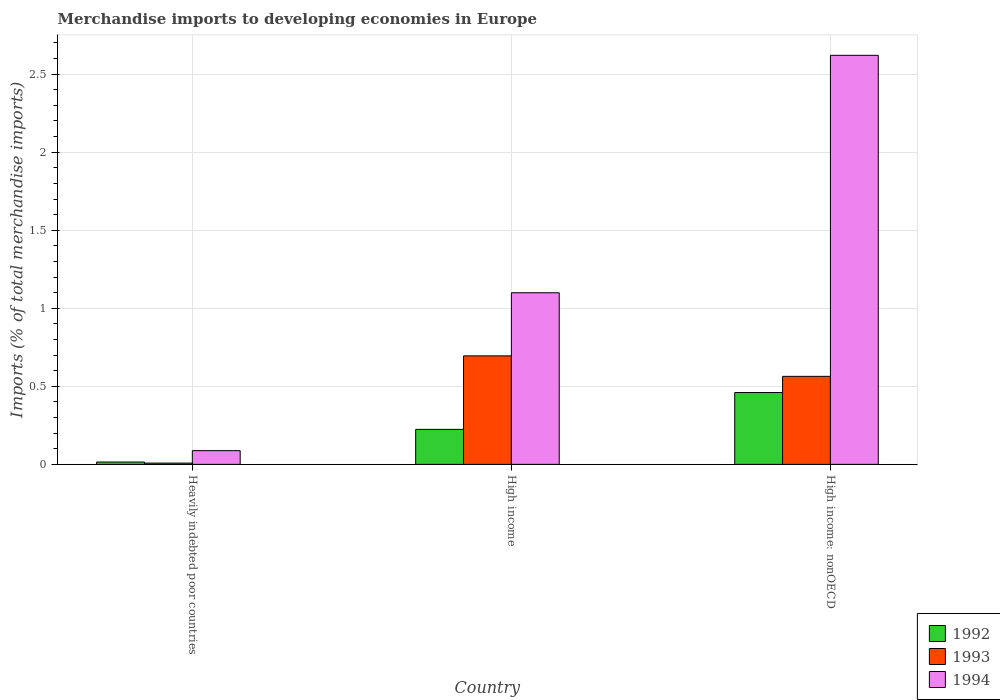Are the number of bars per tick equal to the number of legend labels?
Your response must be concise. Yes. Are the number of bars on each tick of the X-axis equal?
Ensure brevity in your answer.  Yes. How many bars are there on the 3rd tick from the right?
Give a very brief answer. 3. What is the label of the 3rd group of bars from the left?
Make the answer very short. High income: nonOECD. What is the percentage total merchandise imports in 1994 in High income?
Your answer should be very brief. 1.1. Across all countries, what is the maximum percentage total merchandise imports in 1993?
Provide a short and direct response. 0.7. Across all countries, what is the minimum percentage total merchandise imports in 1994?
Make the answer very short. 0.09. In which country was the percentage total merchandise imports in 1994 maximum?
Offer a terse response. High income: nonOECD. In which country was the percentage total merchandise imports in 1993 minimum?
Give a very brief answer. Heavily indebted poor countries. What is the total percentage total merchandise imports in 1993 in the graph?
Your response must be concise. 1.27. What is the difference between the percentage total merchandise imports in 1994 in Heavily indebted poor countries and that in High income?
Provide a short and direct response. -1.01. What is the difference between the percentage total merchandise imports in 1992 in High income and the percentage total merchandise imports in 1993 in Heavily indebted poor countries?
Give a very brief answer. 0.22. What is the average percentage total merchandise imports in 1994 per country?
Offer a terse response. 1.27. What is the difference between the percentage total merchandise imports of/in 1992 and percentage total merchandise imports of/in 1994 in High income: nonOECD?
Ensure brevity in your answer.  -2.16. In how many countries, is the percentage total merchandise imports in 1993 greater than 2.4 %?
Offer a very short reply. 0. What is the ratio of the percentage total merchandise imports in 1993 in Heavily indebted poor countries to that in High income?
Offer a very short reply. 0.01. Is the difference between the percentage total merchandise imports in 1992 in Heavily indebted poor countries and High income greater than the difference between the percentage total merchandise imports in 1994 in Heavily indebted poor countries and High income?
Provide a succinct answer. Yes. What is the difference between the highest and the second highest percentage total merchandise imports in 1994?
Give a very brief answer. -1.01. What is the difference between the highest and the lowest percentage total merchandise imports in 1994?
Provide a succinct answer. 2.53. Is the sum of the percentage total merchandise imports in 1994 in High income and High income: nonOECD greater than the maximum percentage total merchandise imports in 1993 across all countries?
Provide a short and direct response. Yes. What does the 2nd bar from the left in Heavily indebted poor countries represents?
Provide a succinct answer. 1993. Is it the case that in every country, the sum of the percentage total merchandise imports in 1994 and percentage total merchandise imports in 1993 is greater than the percentage total merchandise imports in 1992?
Provide a succinct answer. Yes. Are all the bars in the graph horizontal?
Your answer should be very brief. No. Does the graph contain grids?
Offer a terse response. Yes. How are the legend labels stacked?
Your answer should be compact. Vertical. What is the title of the graph?
Give a very brief answer. Merchandise imports to developing economies in Europe. What is the label or title of the Y-axis?
Your answer should be compact. Imports (% of total merchandise imports). What is the Imports (% of total merchandise imports) of 1992 in Heavily indebted poor countries?
Keep it short and to the point. 0.02. What is the Imports (% of total merchandise imports) in 1993 in Heavily indebted poor countries?
Offer a terse response. 0.01. What is the Imports (% of total merchandise imports) of 1994 in Heavily indebted poor countries?
Provide a short and direct response. 0.09. What is the Imports (% of total merchandise imports) of 1992 in High income?
Make the answer very short. 0.22. What is the Imports (% of total merchandise imports) in 1993 in High income?
Provide a short and direct response. 0.7. What is the Imports (% of total merchandise imports) of 1994 in High income?
Ensure brevity in your answer.  1.1. What is the Imports (% of total merchandise imports) of 1992 in High income: nonOECD?
Give a very brief answer. 0.46. What is the Imports (% of total merchandise imports) in 1993 in High income: nonOECD?
Your answer should be compact. 0.56. What is the Imports (% of total merchandise imports) in 1994 in High income: nonOECD?
Give a very brief answer. 2.62. Across all countries, what is the maximum Imports (% of total merchandise imports) in 1992?
Give a very brief answer. 0.46. Across all countries, what is the maximum Imports (% of total merchandise imports) of 1993?
Offer a terse response. 0.7. Across all countries, what is the maximum Imports (% of total merchandise imports) of 1994?
Make the answer very short. 2.62. Across all countries, what is the minimum Imports (% of total merchandise imports) in 1992?
Your answer should be compact. 0.02. Across all countries, what is the minimum Imports (% of total merchandise imports) in 1993?
Ensure brevity in your answer.  0.01. Across all countries, what is the minimum Imports (% of total merchandise imports) in 1994?
Offer a very short reply. 0.09. What is the total Imports (% of total merchandise imports) in 1992 in the graph?
Provide a succinct answer. 0.7. What is the total Imports (% of total merchandise imports) in 1993 in the graph?
Your response must be concise. 1.27. What is the total Imports (% of total merchandise imports) of 1994 in the graph?
Make the answer very short. 3.81. What is the difference between the Imports (% of total merchandise imports) of 1992 in Heavily indebted poor countries and that in High income?
Your answer should be very brief. -0.21. What is the difference between the Imports (% of total merchandise imports) in 1993 in Heavily indebted poor countries and that in High income?
Your answer should be compact. -0.69. What is the difference between the Imports (% of total merchandise imports) in 1994 in Heavily indebted poor countries and that in High income?
Ensure brevity in your answer.  -1.01. What is the difference between the Imports (% of total merchandise imports) in 1992 in Heavily indebted poor countries and that in High income: nonOECD?
Give a very brief answer. -0.45. What is the difference between the Imports (% of total merchandise imports) in 1993 in Heavily indebted poor countries and that in High income: nonOECD?
Offer a terse response. -0.56. What is the difference between the Imports (% of total merchandise imports) of 1994 in Heavily indebted poor countries and that in High income: nonOECD?
Ensure brevity in your answer.  -2.53. What is the difference between the Imports (% of total merchandise imports) of 1992 in High income and that in High income: nonOECD?
Your answer should be compact. -0.24. What is the difference between the Imports (% of total merchandise imports) in 1993 in High income and that in High income: nonOECD?
Your answer should be very brief. 0.13. What is the difference between the Imports (% of total merchandise imports) of 1994 in High income and that in High income: nonOECD?
Give a very brief answer. -1.52. What is the difference between the Imports (% of total merchandise imports) of 1992 in Heavily indebted poor countries and the Imports (% of total merchandise imports) of 1993 in High income?
Give a very brief answer. -0.68. What is the difference between the Imports (% of total merchandise imports) in 1992 in Heavily indebted poor countries and the Imports (% of total merchandise imports) in 1994 in High income?
Your answer should be very brief. -1.08. What is the difference between the Imports (% of total merchandise imports) in 1993 in Heavily indebted poor countries and the Imports (% of total merchandise imports) in 1994 in High income?
Your answer should be very brief. -1.09. What is the difference between the Imports (% of total merchandise imports) of 1992 in Heavily indebted poor countries and the Imports (% of total merchandise imports) of 1993 in High income: nonOECD?
Keep it short and to the point. -0.55. What is the difference between the Imports (% of total merchandise imports) of 1992 in Heavily indebted poor countries and the Imports (% of total merchandise imports) of 1994 in High income: nonOECD?
Your answer should be very brief. -2.61. What is the difference between the Imports (% of total merchandise imports) of 1993 in Heavily indebted poor countries and the Imports (% of total merchandise imports) of 1994 in High income: nonOECD?
Provide a short and direct response. -2.61. What is the difference between the Imports (% of total merchandise imports) of 1992 in High income and the Imports (% of total merchandise imports) of 1993 in High income: nonOECD?
Make the answer very short. -0.34. What is the difference between the Imports (% of total merchandise imports) in 1992 in High income and the Imports (% of total merchandise imports) in 1994 in High income: nonOECD?
Make the answer very short. -2.4. What is the difference between the Imports (% of total merchandise imports) in 1993 in High income and the Imports (% of total merchandise imports) in 1994 in High income: nonOECD?
Offer a terse response. -1.93. What is the average Imports (% of total merchandise imports) of 1992 per country?
Your answer should be very brief. 0.23. What is the average Imports (% of total merchandise imports) in 1993 per country?
Make the answer very short. 0.42. What is the average Imports (% of total merchandise imports) in 1994 per country?
Keep it short and to the point. 1.27. What is the difference between the Imports (% of total merchandise imports) in 1992 and Imports (% of total merchandise imports) in 1993 in Heavily indebted poor countries?
Offer a very short reply. 0.01. What is the difference between the Imports (% of total merchandise imports) in 1992 and Imports (% of total merchandise imports) in 1994 in Heavily indebted poor countries?
Provide a short and direct response. -0.07. What is the difference between the Imports (% of total merchandise imports) in 1993 and Imports (% of total merchandise imports) in 1994 in Heavily indebted poor countries?
Provide a succinct answer. -0.08. What is the difference between the Imports (% of total merchandise imports) in 1992 and Imports (% of total merchandise imports) in 1993 in High income?
Provide a succinct answer. -0.47. What is the difference between the Imports (% of total merchandise imports) in 1992 and Imports (% of total merchandise imports) in 1994 in High income?
Your answer should be compact. -0.88. What is the difference between the Imports (% of total merchandise imports) of 1993 and Imports (% of total merchandise imports) of 1994 in High income?
Keep it short and to the point. -0.4. What is the difference between the Imports (% of total merchandise imports) of 1992 and Imports (% of total merchandise imports) of 1993 in High income: nonOECD?
Make the answer very short. -0.1. What is the difference between the Imports (% of total merchandise imports) of 1992 and Imports (% of total merchandise imports) of 1994 in High income: nonOECD?
Offer a terse response. -2.16. What is the difference between the Imports (% of total merchandise imports) of 1993 and Imports (% of total merchandise imports) of 1994 in High income: nonOECD?
Your answer should be very brief. -2.06. What is the ratio of the Imports (% of total merchandise imports) in 1992 in Heavily indebted poor countries to that in High income?
Your answer should be compact. 0.07. What is the ratio of the Imports (% of total merchandise imports) in 1993 in Heavily indebted poor countries to that in High income?
Offer a very short reply. 0.01. What is the ratio of the Imports (% of total merchandise imports) in 1992 in Heavily indebted poor countries to that in High income: nonOECD?
Ensure brevity in your answer.  0.03. What is the ratio of the Imports (% of total merchandise imports) in 1993 in Heavily indebted poor countries to that in High income: nonOECD?
Offer a very short reply. 0.01. What is the ratio of the Imports (% of total merchandise imports) of 1994 in Heavily indebted poor countries to that in High income: nonOECD?
Your response must be concise. 0.03. What is the ratio of the Imports (% of total merchandise imports) in 1992 in High income to that in High income: nonOECD?
Keep it short and to the point. 0.49. What is the ratio of the Imports (% of total merchandise imports) in 1993 in High income to that in High income: nonOECD?
Your response must be concise. 1.23. What is the ratio of the Imports (% of total merchandise imports) in 1994 in High income to that in High income: nonOECD?
Offer a terse response. 0.42. What is the difference between the highest and the second highest Imports (% of total merchandise imports) of 1992?
Ensure brevity in your answer.  0.24. What is the difference between the highest and the second highest Imports (% of total merchandise imports) in 1993?
Ensure brevity in your answer.  0.13. What is the difference between the highest and the second highest Imports (% of total merchandise imports) in 1994?
Provide a short and direct response. 1.52. What is the difference between the highest and the lowest Imports (% of total merchandise imports) of 1992?
Your response must be concise. 0.45. What is the difference between the highest and the lowest Imports (% of total merchandise imports) of 1993?
Your response must be concise. 0.69. What is the difference between the highest and the lowest Imports (% of total merchandise imports) in 1994?
Your response must be concise. 2.53. 